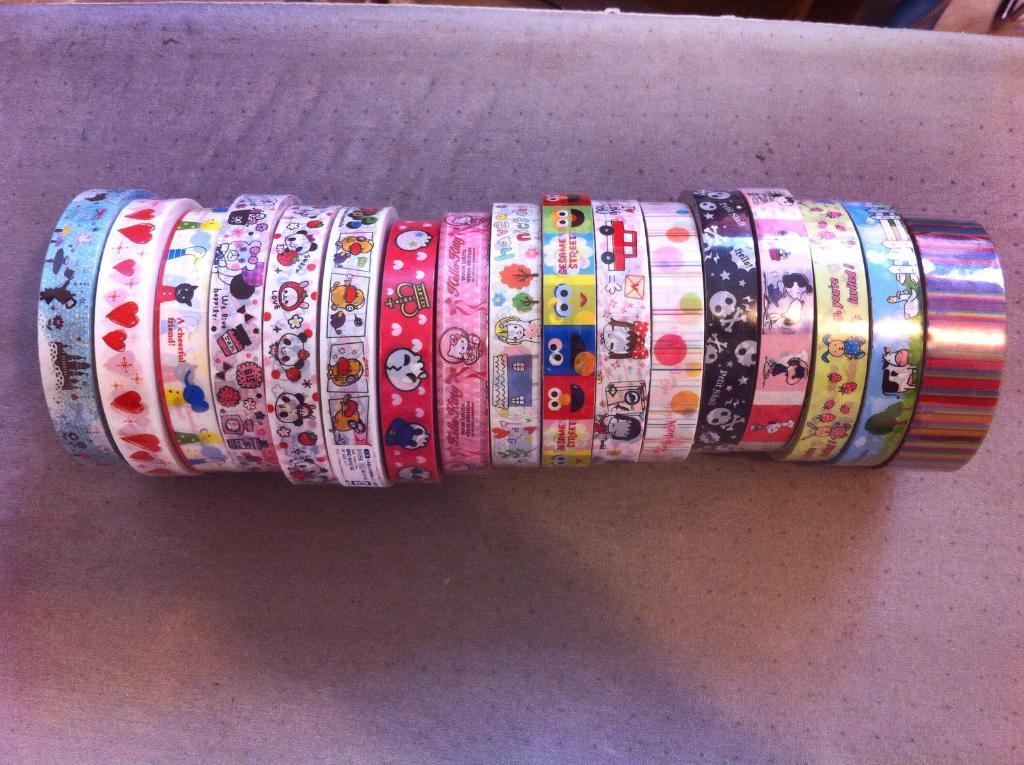Describe this image in one or two sentences. In this picture I can see there are different colors and designs of tapes arranged in a line and they are placed on a plane surface. 